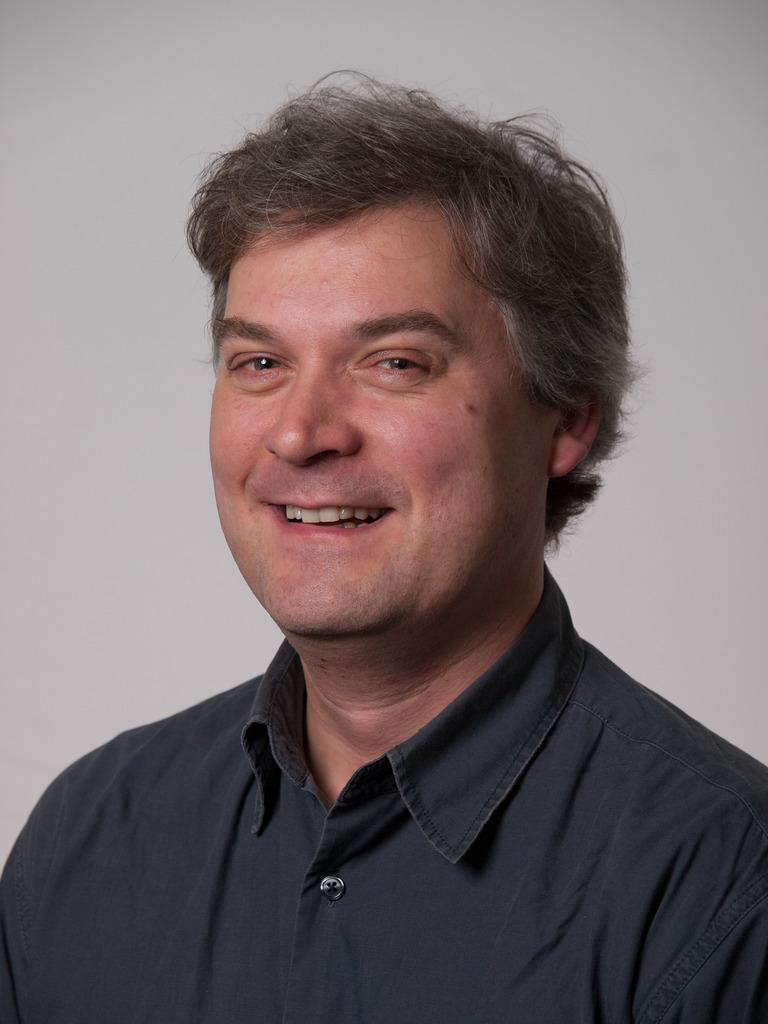What is the main subject of the image? There is a man in the image. What is the man wearing? The man is wearing a black shirt. What expression does the man have? The man is smiling. Can you describe the background of the image? There might be a wall in the background of the image. What type of potato is the man attempting to measure in the image? There is no potato present in the image, and the man is not attempting to measure anything. 